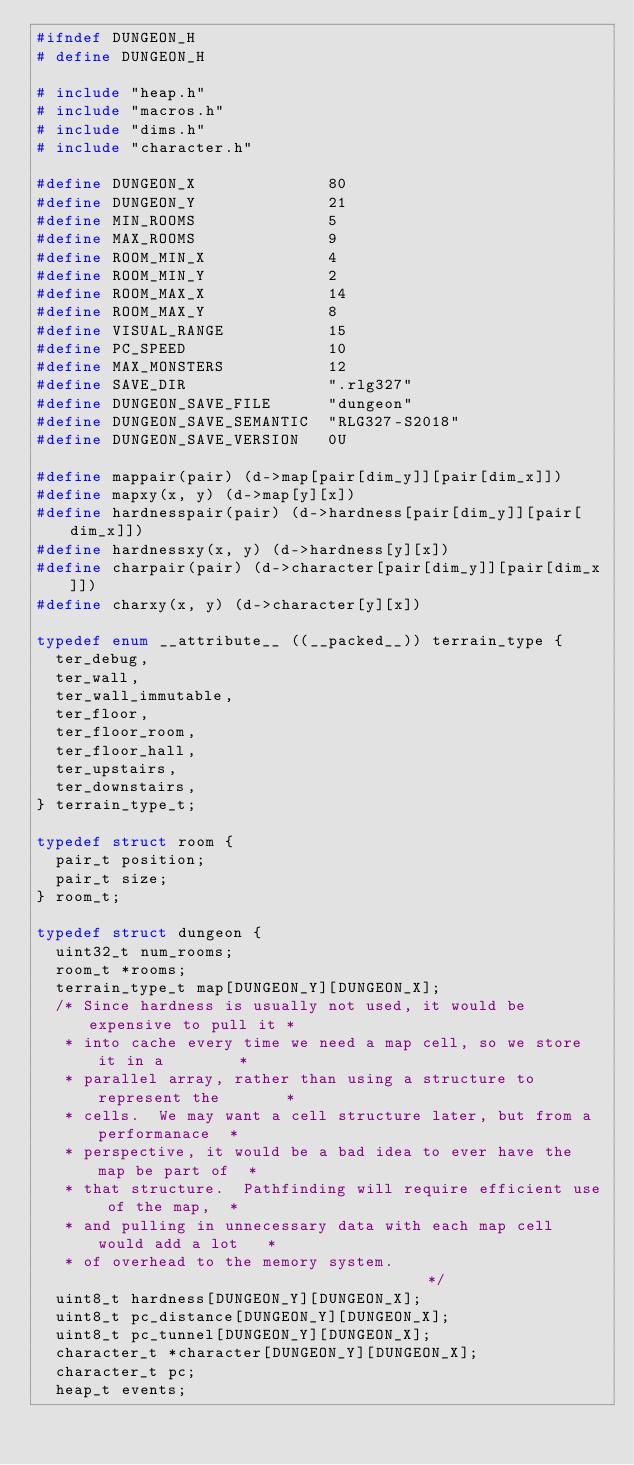<code> <loc_0><loc_0><loc_500><loc_500><_C_>#ifndef DUNGEON_H
# define DUNGEON_H

# include "heap.h"
# include "macros.h"
# include "dims.h"
# include "character.h"

#define DUNGEON_X              80
#define DUNGEON_Y              21
#define MIN_ROOMS              5
#define MAX_ROOMS              9
#define ROOM_MIN_X             4
#define ROOM_MIN_Y             2
#define ROOM_MAX_X             14
#define ROOM_MAX_Y             8
#define VISUAL_RANGE           15
#define PC_SPEED               10
#define MAX_MONSTERS           12
#define SAVE_DIR               ".rlg327"
#define DUNGEON_SAVE_FILE      "dungeon"
#define DUNGEON_SAVE_SEMANTIC  "RLG327-S2018"
#define DUNGEON_SAVE_VERSION   0U

#define mappair(pair) (d->map[pair[dim_y]][pair[dim_x]])
#define mapxy(x, y) (d->map[y][x])
#define hardnesspair(pair) (d->hardness[pair[dim_y]][pair[dim_x]])
#define hardnessxy(x, y) (d->hardness[y][x])
#define charpair(pair) (d->character[pair[dim_y]][pair[dim_x]])
#define charxy(x, y) (d->character[y][x])

typedef enum __attribute__ ((__packed__)) terrain_type {
  ter_debug,
  ter_wall,
  ter_wall_immutable,
  ter_floor,
  ter_floor_room,
  ter_floor_hall,
  ter_upstairs,
  ter_downstairs,
} terrain_type_t;

typedef struct room {
  pair_t position;
  pair_t size;
} room_t;

typedef struct dungeon {
  uint32_t num_rooms;
  room_t *rooms;
  terrain_type_t map[DUNGEON_Y][DUNGEON_X];
  /* Since hardness is usually not used, it would be expensive to pull it *
   * into cache every time we need a map cell, so we store it in a        *
   * parallel array, rather than using a structure to represent the       *
   * cells.  We may want a cell structure later, but from a performanace  *
   * perspective, it would be a bad idea to ever have the map be part of  *
   * that structure.  Pathfinding will require efficient use of the map,  *
   * and pulling in unnecessary data with each map cell would add a lot   *
   * of overhead to the memory system.                                    */
  uint8_t hardness[DUNGEON_Y][DUNGEON_X];
  uint8_t pc_distance[DUNGEON_Y][DUNGEON_X];
  uint8_t pc_tunnel[DUNGEON_Y][DUNGEON_X];
  character_t *character[DUNGEON_Y][DUNGEON_X];
  character_t pc;
  heap_t events;</code> 